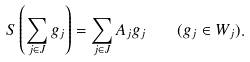<formula> <loc_0><loc_0><loc_500><loc_500>S \left ( \sum _ { j \in J } g _ { j } \right ) = \sum _ { j \in J } A _ { j } g _ { j } \quad ( g _ { j } \in W _ { j } ) .</formula> 